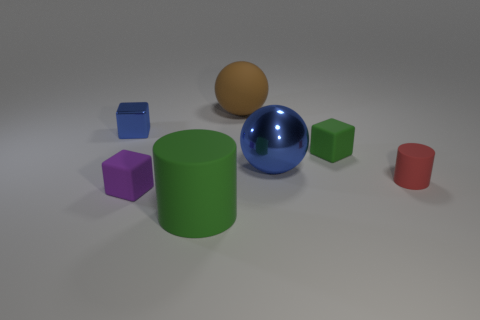Add 2 big blue shiny balls. How many objects exist? 9 Subtract all blocks. How many objects are left? 4 Add 3 matte objects. How many matte objects are left? 8 Add 6 tiny purple matte things. How many tiny purple matte things exist? 7 Subtract 1 blue balls. How many objects are left? 6 Subtract all big cylinders. Subtract all large blue spheres. How many objects are left? 5 